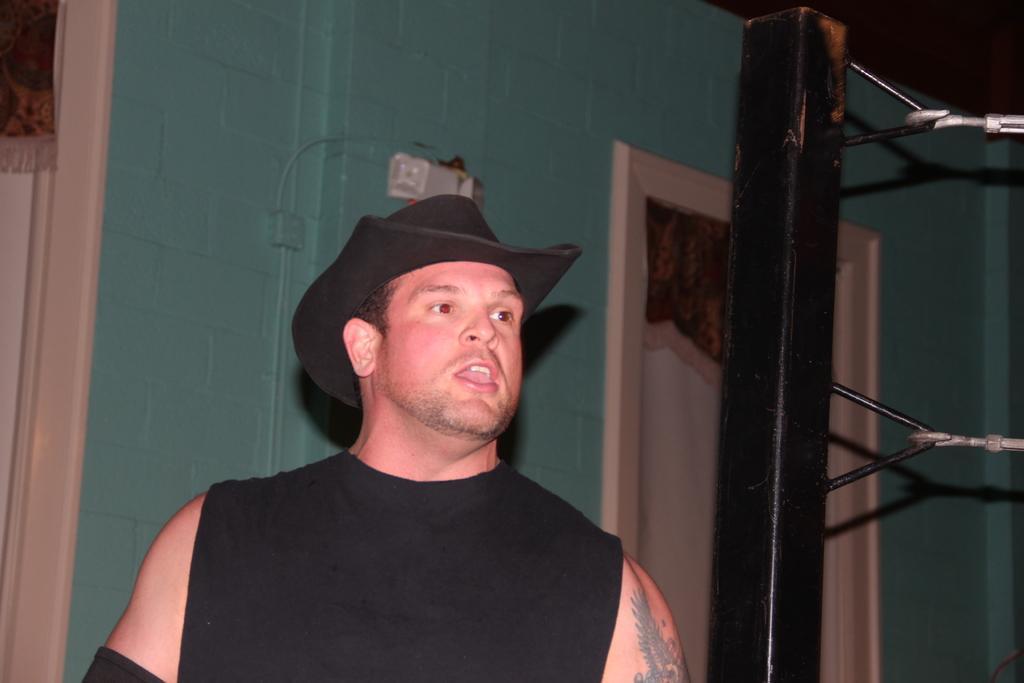Can you describe this image briefly? In this image I can see a man. The man is wearing a black color hat and a black color top. In the background I can see a wall, a wooden pole and some other objects. 